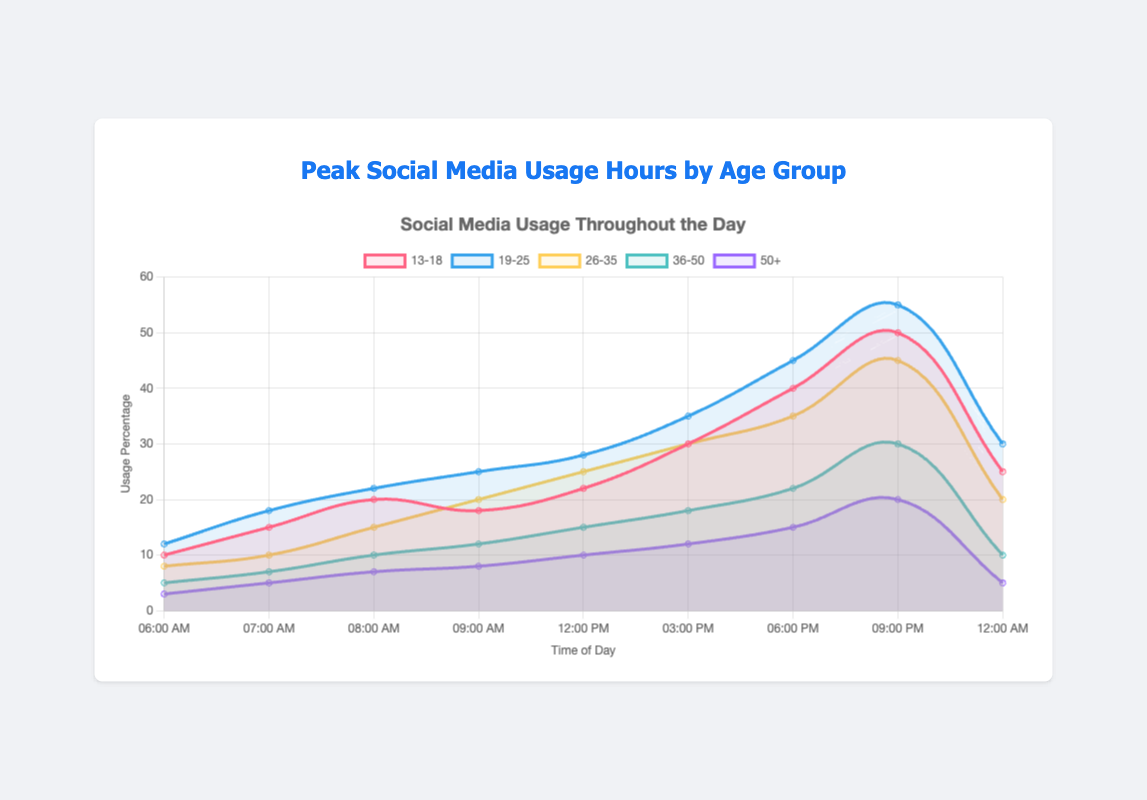What time does the 19-25 age group show the highest social media usage? The highest point on the graph for the 19-25 age group is at 9:00 PM with a usage percentage of 55.
Answer: 9:00 PM Which age group has the lowest social media usage at 6:00 AM? At 6:00 AM, the 50+ age group shows a usage percentage of 3, which is the lowest compared to other age groups.
Answer: 50+ By how much does the social media usage of the 13-18 age group increase from 3:00 PM to 9:00 PM? The usage percentage at 3:00 PM is 30 and at 9:00 PM is 50. The increase is 50 - 30 = 20 percentage points.
Answer: 20 percentage points At 12:00 PM, which age group uses social media more, the 26-35 group or the 36-50 group? At 12:00 PM, the 26-35 age group has a usage percentage of 25, whereas the 36-50 age group has a usage percentage of 15.
Answer: 26-35 group On average, what is the social media usage percentage for the 13-18 age group across all recorded times? The usage percentages for the 13-18 age group are 10, 15, 20, 18, 22, 30, 40, 50, and 25. Summing these gives 230. Dividing by the number of points (9) gives an average of 230 / 9 ≈ 25.56.
Answer: ≈ 25.56 At what time does the 50+ age group have the smallest usage difference compared to the 26-35 age group? By comparing the usage percentages, it becomes clear that at 12:00 PM, the 50+ group has 10%, and the 26-35 group has 25%. The difference is 25 - 10 = 15, which appears to be the smallest compared to differences at other times.
Answer: 12:00 PM Is there a time when all age groups have an increased usage compared to the previous hour shown? At 7:00 AM, all age groups show increased usage compared to 6:00 AM.
Answer: 7:00 AM What is the peak usage percentage for the 36-50 age group and at what time does it occur? The peak usage for the 36-50 age group is 30%, which occurs at 9:00 PM.
Answer: 9:00 PM 